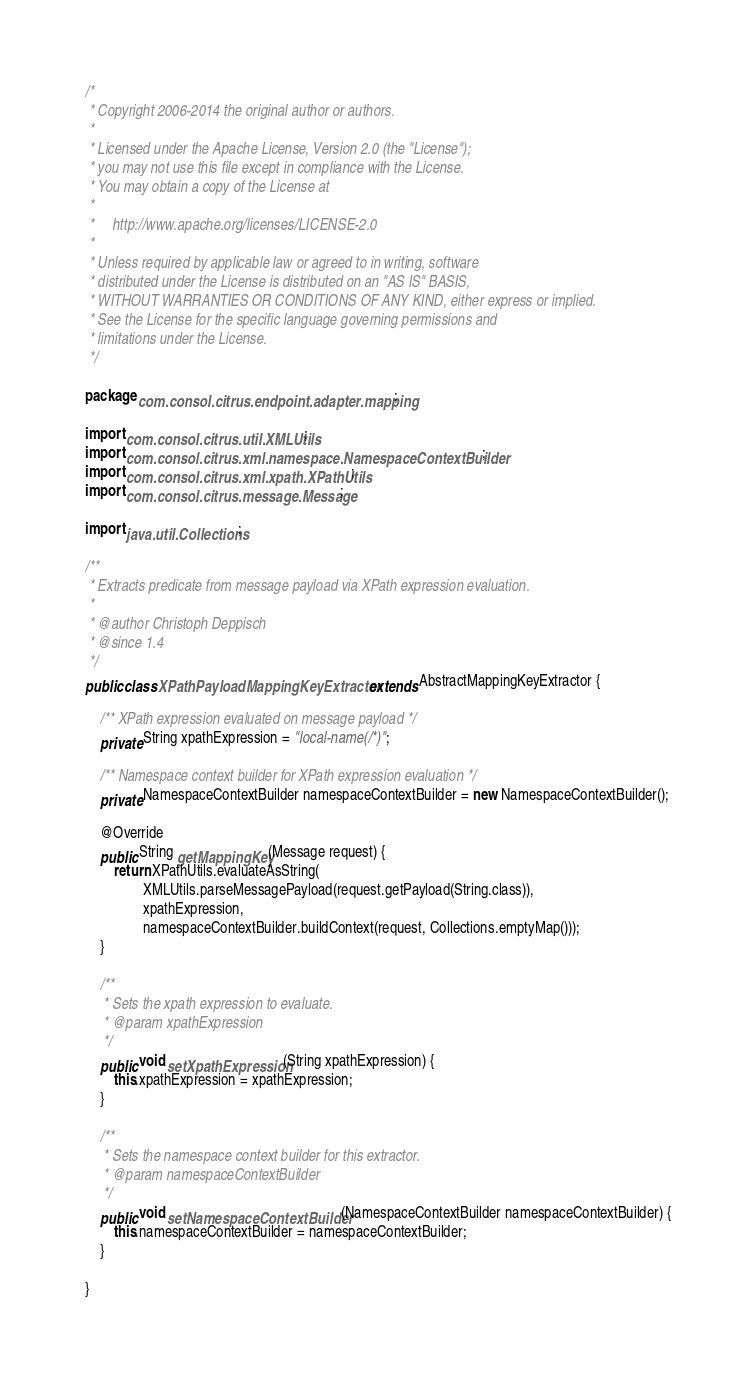Convert code to text. <code><loc_0><loc_0><loc_500><loc_500><_Java_>/*
 * Copyright 2006-2014 the original author or authors.
 *
 * Licensed under the Apache License, Version 2.0 (the "License");
 * you may not use this file except in compliance with the License.
 * You may obtain a copy of the License at
 *
 *     http://www.apache.org/licenses/LICENSE-2.0
 *
 * Unless required by applicable law or agreed to in writing, software
 * distributed under the License is distributed on an "AS IS" BASIS,
 * WITHOUT WARRANTIES OR CONDITIONS OF ANY KIND, either express or implied.
 * See the License for the specific language governing permissions and
 * limitations under the License.
 */

package com.consol.citrus.endpoint.adapter.mapping;

import com.consol.citrus.util.XMLUtils;
import com.consol.citrus.xml.namespace.NamespaceContextBuilder;
import com.consol.citrus.xml.xpath.XPathUtils;
import com.consol.citrus.message.Message;

import java.util.Collections;

/**
 * Extracts predicate from message payload via XPath expression evaluation.
 *
 * @author Christoph Deppisch
 * @since 1.4
 */
public class XPathPayloadMappingKeyExtractor extends AbstractMappingKeyExtractor {

    /** XPath expression evaluated on message payload */
    private String xpathExpression = "local-name(/*)";

    /** Namespace context builder for XPath expression evaluation */
    private NamespaceContextBuilder namespaceContextBuilder = new NamespaceContextBuilder();

    @Override
    public String getMappingKey(Message request) {
        return XPathUtils.evaluateAsString(
                XMLUtils.parseMessagePayload(request.getPayload(String.class)),
                xpathExpression,
                namespaceContextBuilder.buildContext(request, Collections.emptyMap()));
    }

    /**
     * Sets the xpath expression to evaluate.
     * @param xpathExpression
     */
    public void setXpathExpression(String xpathExpression) {
        this.xpathExpression = xpathExpression;
    }

    /**
     * Sets the namespace context builder for this extractor.
     * @param namespaceContextBuilder
     */
    public void setNamespaceContextBuilder(NamespaceContextBuilder namespaceContextBuilder) {
        this.namespaceContextBuilder = namespaceContextBuilder;
    }

}
</code> 